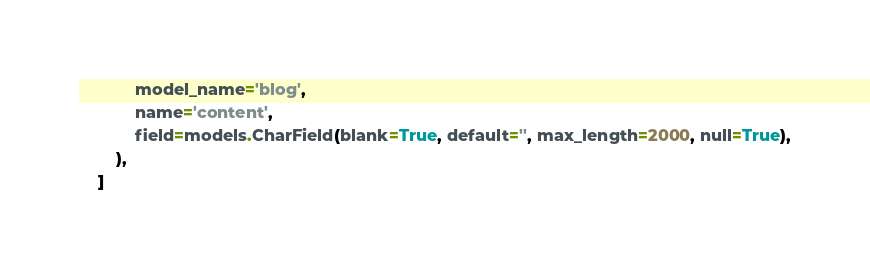Convert code to text. <code><loc_0><loc_0><loc_500><loc_500><_Python_>            model_name='blog',
            name='content',
            field=models.CharField(blank=True, default='', max_length=2000, null=True),
        ),
    ]
</code> 